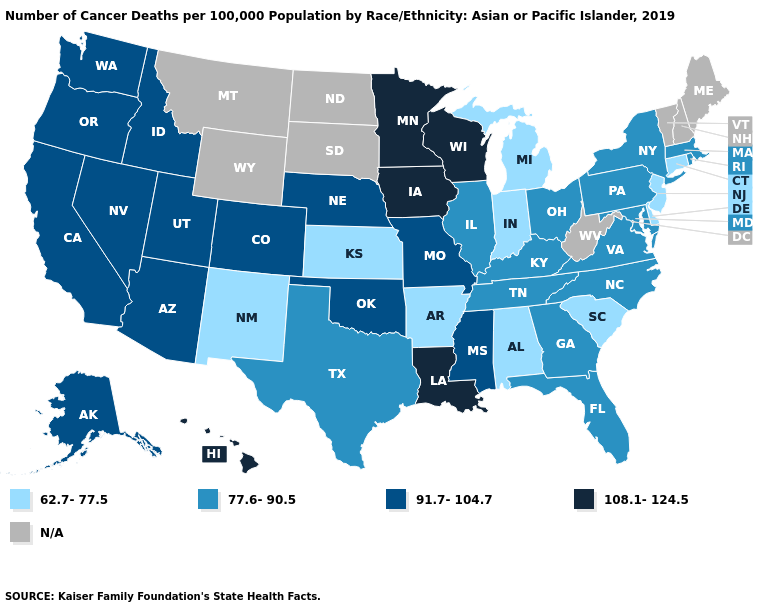Name the states that have a value in the range 77.6-90.5?
Write a very short answer. Florida, Georgia, Illinois, Kentucky, Maryland, Massachusetts, New York, North Carolina, Ohio, Pennsylvania, Rhode Island, Tennessee, Texas, Virginia. Name the states that have a value in the range 62.7-77.5?
Short answer required. Alabama, Arkansas, Connecticut, Delaware, Indiana, Kansas, Michigan, New Jersey, New Mexico, South Carolina. What is the value of Virginia?
Quick response, please. 77.6-90.5. Which states hav the highest value in the West?
Give a very brief answer. Hawaii. What is the value of Iowa?
Quick response, please. 108.1-124.5. Which states have the highest value in the USA?
Give a very brief answer. Hawaii, Iowa, Louisiana, Minnesota, Wisconsin. What is the value of Wyoming?
Write a very short answer. N/A. What is the value of Washington?
Be succinct. 91.7-104.7. What is the value of Tennessee?
Give a very brief answer. 77.6-90.5. Among the states that border Kansas , which have the highest value?
Keep it brief. Colorado, Missouri, Nebraska, Oklahoma. Name the states that have a value in the range 62.7-77.5?
Concise answer only. Alabama, Arkansas, Connecticut, Delaware, Indiana, Kansas, Michigan, New Jersey, New Mexico, South Carolina. Name the states that have a value in the range 108.1-124.5?
Keep it brief. Hawaii, Iowa, Louisiana, Minnesota, Wisconsin. Does Louisiana have the highest value in the South?
Concise answer only. Yes. What is the value of South Carolina?
Short answer required. 62.7-77.5. 